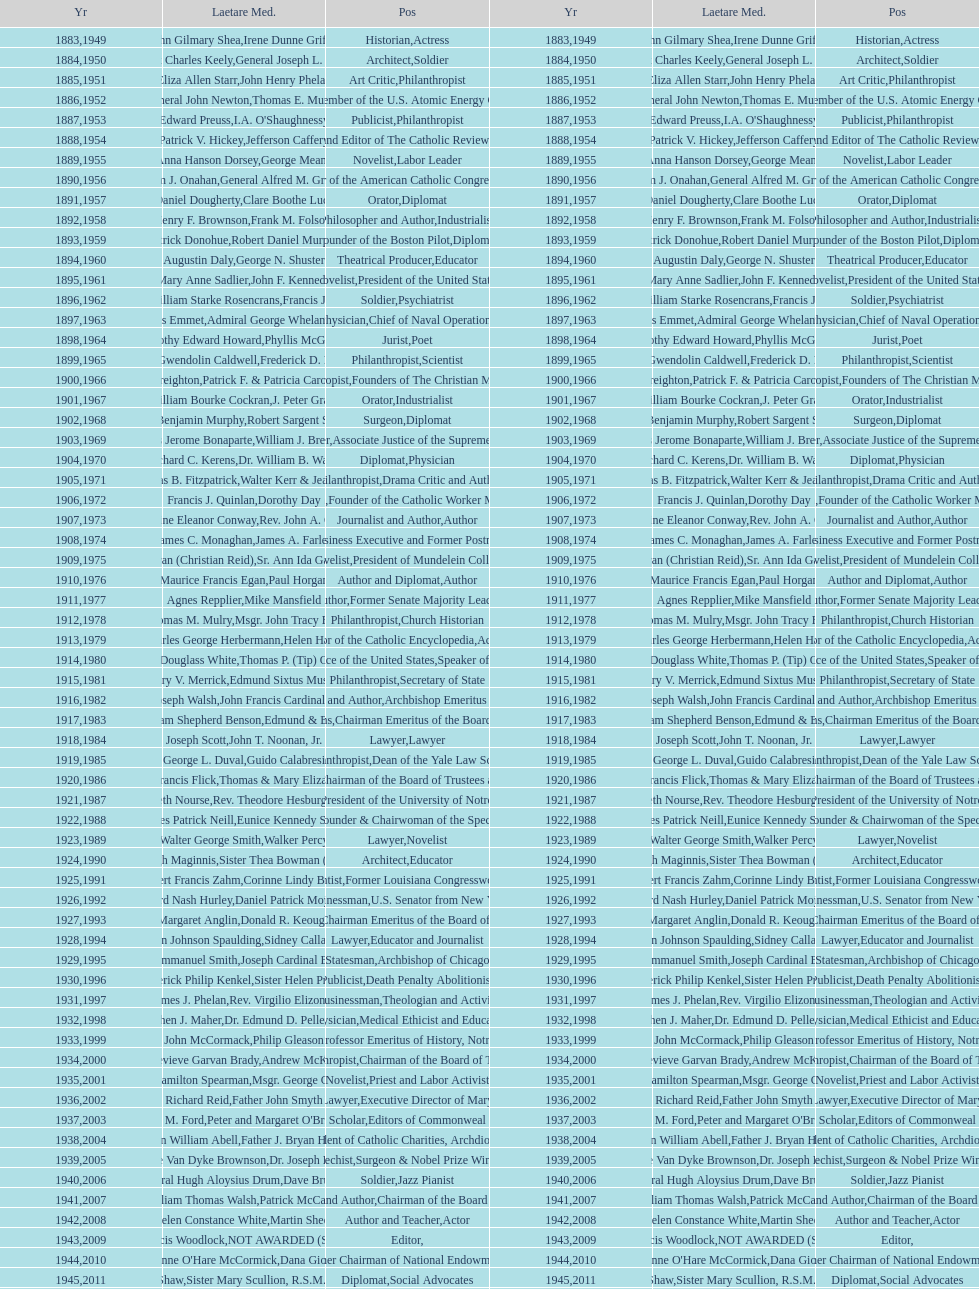In the position column on this chart, how frequently does the word "philanthropist" occur? 9. 